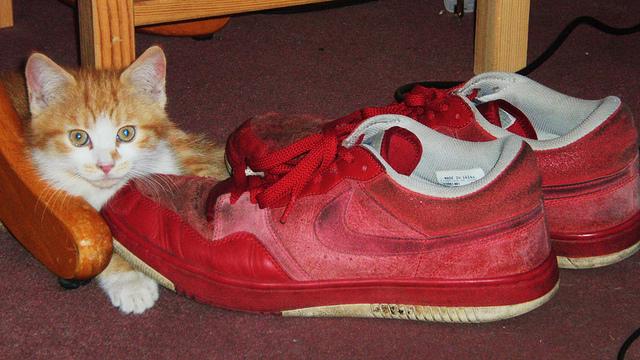What brand of shoes are those?
Give a very brief answer. Nike. What type of cat is this?
Quick response, please. Tabby. What color is the shoe?
Quick response, please. Red. What color are the sneakers?
Be succinct. Red. What color are the laces?
Quick response, please. Red. 